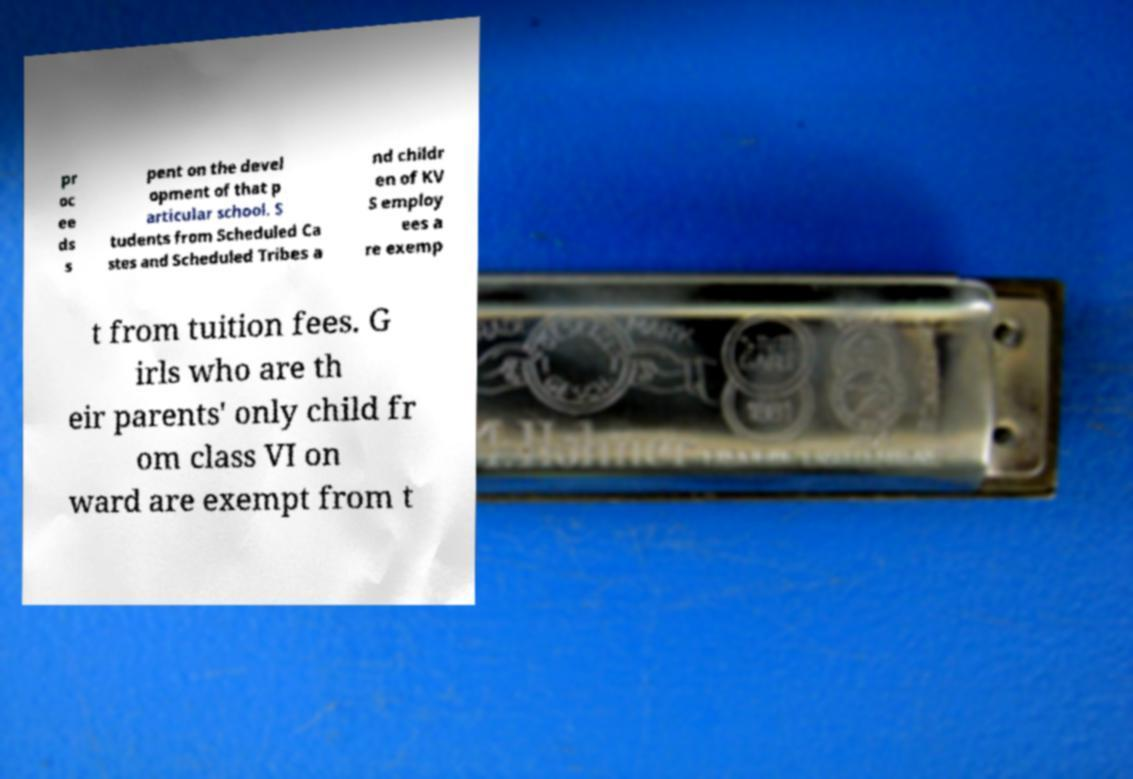Please read and relay the text visible in this image. What does it say? pr oc ee ds s pent on the devel opment of that p articular school. S tudents from Scheduled Ca stes and Scheduled Tribes a nd childr en of KV S employ ees a re exemp t from tuition fees. G irls who are th eir parents' only child fr om class VI on ward are exempt from t 